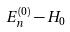Convert formula to latex. <formula><loc_0><loc_0><loc_500><loc_500>E _ { n } ^ { ( 0 ) } - H _ { 0 }</formula> 